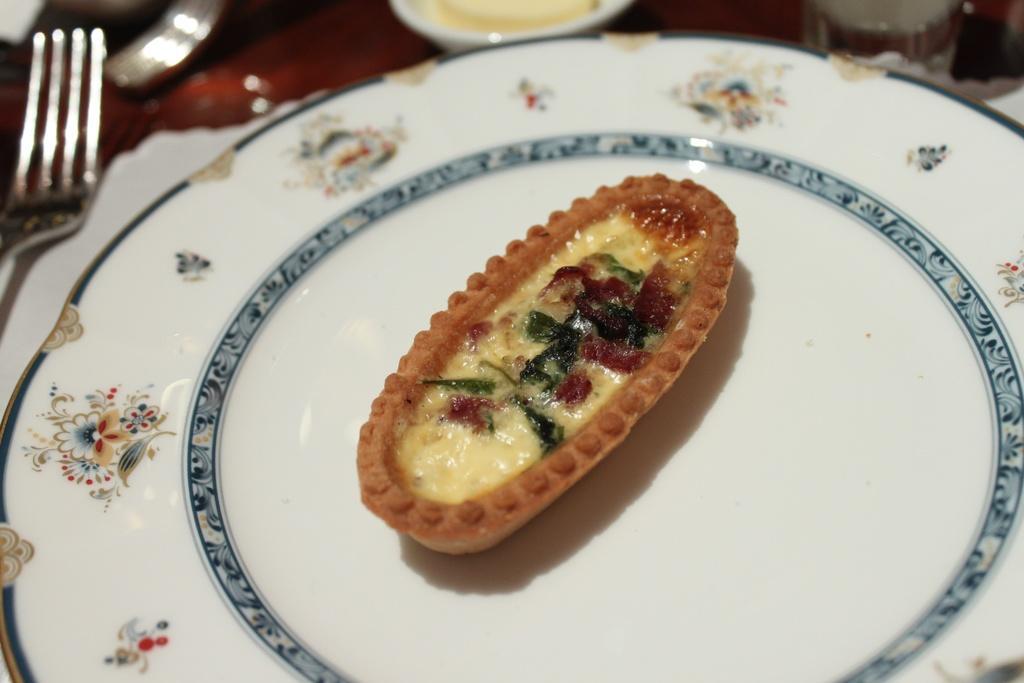Could you give a brief overview of what you see in this image? In this picture we can see a table, there is a plate, a fork, a cup present on the table, we can see some food in this plate, there is a blurry background. 